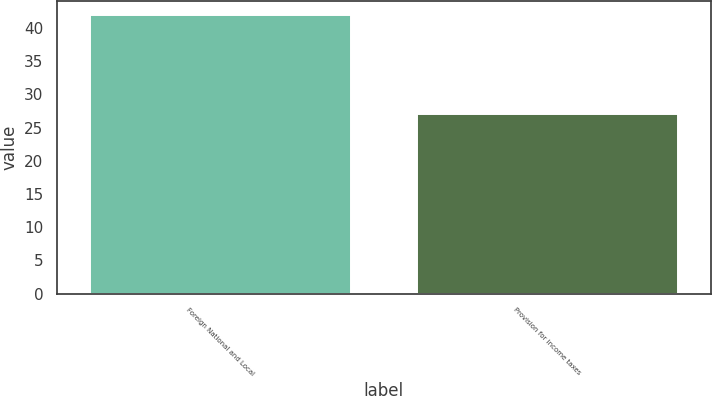Convert chart to OTSL. <chart><loc_0><loc_0><loc_500><loc_500><bar_chart><fcel>Foreign National and Local<fcel>Provision for income taxes<nl><fcel>42<fcel>27<nl></chart> 